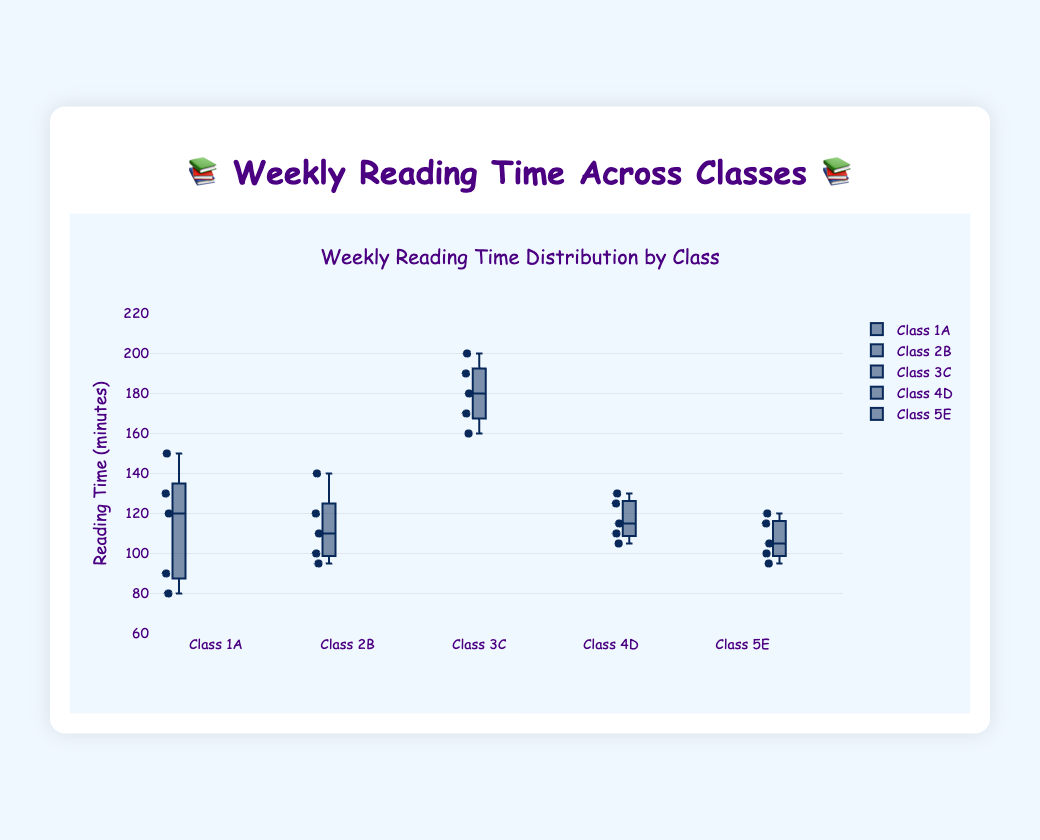What is the title of the figure? The title is usually located at the top of the figure and indicates what the plot is about. From the provided details, the title is "Weekly Reading Time Distribution by Class".
Answer: Weekly Reading Time Distribution by Class Which class has the highest median weekly reading time? Box plots display the median as a line within the box. By examining the medians, "Class 3C" has the highest median weekly reading time.
Answer: Class 3C What is the range of the reading times for Class 2B? The range of a box plot is determined by the distance between the minimum and maximum values. For Class 2B, the minimum reading time is around 95 minutes, and the maximum is around 140 minutes. Therefore, the range is 140 - 95 = 45 minutes.
Answer: 45 minutes Which class has the most consistent reading times among its students? Consistency in a box plot can be observed by the interquartile range (IQR), which is the length of the box. The smaller the IQR, the more consistent the data. "Class 3C" has the smallest IQR, indicating the most consistent reading times.
Answer: Class 3C How many outliers are present in Class 1A? Outliers in box plots are usually represented by dots outside the 'whiskers' of the box plot. From the visual details, Class 1A has one outlier on the lower end.
Answer: 1 outlier What is the median reading time for Class 5E? The median is the line within the box of the box plot. For Class 5E, the median reading time is around 105 minutes.
Answer: 105 minutes Which class has the widest interquartile range (IQR)? The IQR is the length of the box in the box plot. By visual inspection, Class 3C has the widest IQR, indicating the most variability within the upper and lower quartiles.
Answer: Class 3C What is the maximum reading time recorded for Class 3C? The maximum value in a box plot is the highest value within the whiskers. For Class 3C, this value is around 200 minutes.
Answer: 200 minutes Compare the medians of Class 2B and Class 4D. Which class has a higher median? The median is the central line within the box of a box plot. Comparing them, Class 4D's median (around 115 minutes) is less than Class 2B's median (around 120 minutes). Therefore, Class 2B has a higher median.
Answer: Class 2B 